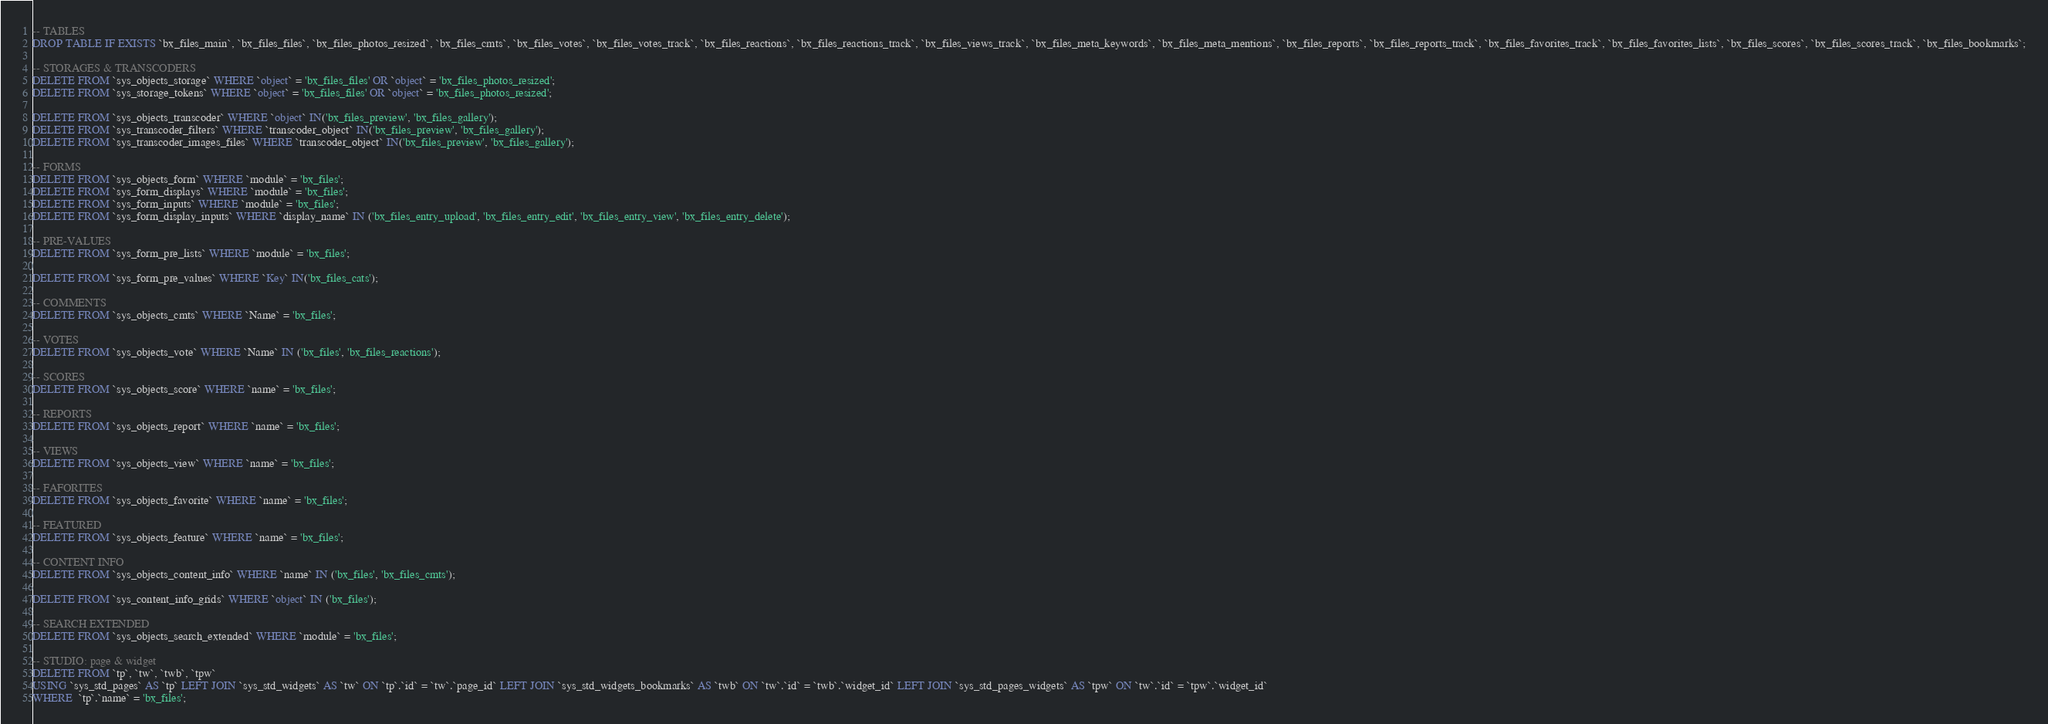Convert code to text. <code><loc_0><loc_0><loc_500><loc_500><_SQL_>
-- TABLES
DROP TABLE IF EXISTS `bx_files_main`, `bx_files_files`, `bx_files_photos_resized`, `bx_files_cmts`, `bx_files_votes`, `bx_files_votes_track`, `bx_files_reactions`, `bx_files_reactions_track`, `bx_files_views_track`, `bx_files_meta_keywords`, `bx_files_meta_mentions`, `bx_files_reports`, `bx_files_reports_track`, `bx_files_favorites_track`, `bx_files_favorites_lists`, `bx_files_scores`, `bx_files_scores_track`, `bx_files_bookmarks`;

-- STORAGES & TRANSCODERS
DELETE FROM `sys_objects_storage` WHERE `object` = 'bx_files_files' OR `object` = 'bx_files_photos_resized';
DELETE FROM `sys_storage_tokens` WHERE `object` = 'bx_files_files' OR `object` = 'bx_files_photos_resized';

DELETE FROM `sys_objects_transcoder` WHERE `object` IN('bx_files_preview', 'bx_files_gallery');
DELETE FROM `sys_transcoder_filters` WHERE `transcoder_object` IN('bx_files_preview', 'bx_files_gallery');
DELETE FROM `sys_transcoder_images_files` WHERE `transcoder_object` IN('bx_files_preview', 'bx_files_gallery');

-- FORMS
DELETE FROM `sys_objects_form` WHERE `module` = 'bx_files';
DELETE FROM `sys_form_displays` WHERE `module` = 'bx_files';
DELETE FROM `sys_form_inputs` WHERE `module` = 'bx_files';
DELETE FROM `sys_form_display_inputs` WHERE `display_name` IN ('bx_files_entry_upload', 'bx_files_entry_edit', 'bx_files_entry_view', 'bx_files_entry_delete');

-- PRE-VALUES
DELETE FROM `sys_form_pre_lists` WHERE `module` = 'bx_files';

DELETE FROM `sys_form_pre_values` WHERE `Key` IN('bx_files_cats');

-- COMMENTS
DELETE FROM `sys_objects_cmts` WHERE `Name` = 'bx_files';

-- VOTES
DELETE FROM `sys_objects_vote` WHERE `Name` IN ('bx_files', 'bx_files_reactions');

-- SCORES
DELETE FROM `sys_objects_score` WHERE `name` = 'bx_files';

-- REPORTS
DELETE FROM `sys_objects_report` WHERE `name` = 'bx_files';

-- VIEWS
DELETE FROM `sys_objects_view` WHERE `name` = 'bx_files';

-- FAFORITES
DELETE FROM `sys_objects_favorite` WHERE `name` = 'bx_files';

-- FEATURED
DELETE FROM `sys_objects_feature` WHERE `name` = 'bx_files';

-- CONTENT INFO
DELETE FROM `sys_objects_content_info` WHERE `name` IN ('bx_files', 'bx_files_cmts');

DELETE FROM `sys_content_info_grids` WHERE `object` IN ('bx_files');

-- SEARCH EXTENDED
DELETE FROM `sys_objects_search_extended` WHERE `module` = 'bx_files';

-- STUDIO: page & widget
DELETE FROM `tp`, `tw`, `twb`, `tpw` 
USING `sys_std_pages` AS `tp` LEFT JOIN `sys_std_widgets` AS `tw` ON `tp`.`id` = `tw`.`page_id` LEFT JOIN `sys_std_widgets_bookmarks` AS `twb` ON `tw`.`id` = `twb`.`widget_id` LEFT JOIN `sys_std_pages_widgets` AS `tpw` ON `tw`.`id` = `tpw`.`widget_id`
WHERE  `tp`.`name` = 'bx_files';
</code> 